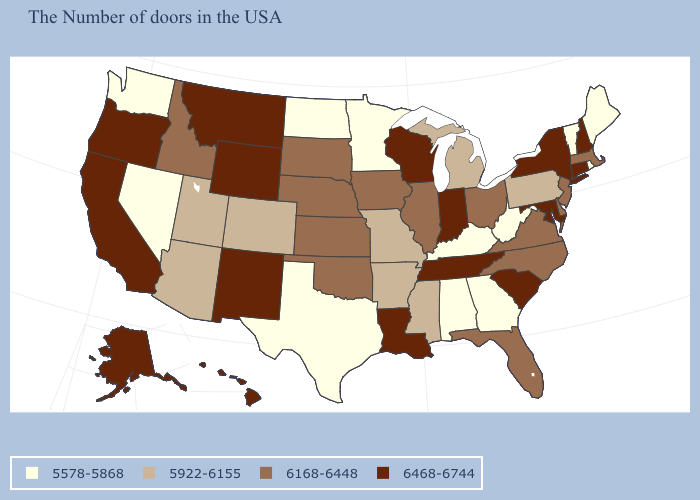Does New Hampshire have the highest value in the USA?
Answer briefly. Yes. Among the states that border Arkansas , does Texas have the lowest value?
Answer briefly. Yes. Is the legend a continuous bar?
Answer briefly. No. Name the states that have a value in the range 6468-6744?
Quick response, please. New Hampshire, Connecticut, New York, Maryland, South Carolina, Indiana, Tennessee, Wisconsin, Louisiana, Wyoming, New Mexico, Montana, California, Oregon, Alaska, Hawaii. Does Louisiana have the highest value in the South?
Be succinct. Yes. Name the states that have a value in the range 6468-6744?
Short answer required. New Hampshire, Connecticut, New York, Maryland, South Carolina, Indiana, Tennessee, Wisconsin, Louisiana, Wyoming, New Mexico, Montana, California, Oregon, Alaska, Hawaii. How many symbols are there in the legend?
Keep it brief. 4. Name the states that have a value in the range 5578-5868?
Answer briefly. Maine, Rhode Island, Vermont, West Virginia, Georgia, Kentucky, Alabama, Minnesota, Texas, North Dakota, Nevada, Washington. Which states have the lowest value in the MidWest?
Concise answer only. Minnesota, North Dakota. What is the highest value in the USA?
Quick response, please. 6468-6744. Name the states that have a value in the range 5922-6155?
Give a very brief answer. Pennsylvania, Michigan, Mississippi, Missouri, Arkansas, Colorado, Utah, Arizona. What is the value of Alabama?
Give a very brief answer. 5578-5868. What is the value of North Carolina?
Concise answer only. 6168-6448. Does Florida have a higher value than Louisiana?
Short answer required. No. What is the value of Indiana?
Quick response, please. 6468-6744. 